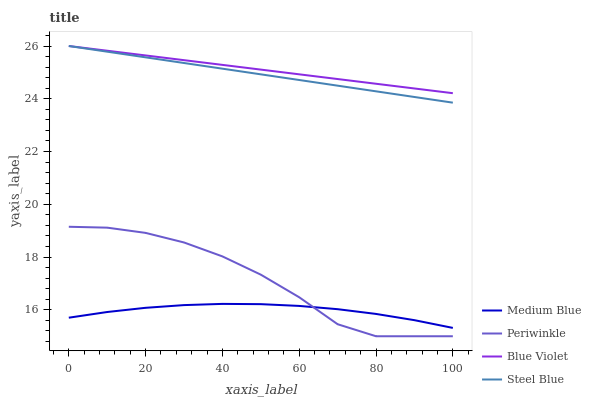Does Medium Blue have the minimum area under the curve?
Answer yes or no. Yes. Does Blue Violet have the maximum area under the curve?
Answer yes or no. Yes. Does Steel Blue have the minimum area under the curve?
Answer yes or no. No. Does Steel Blue have the maximum area under the curve?
Answer yes or no. No. Is Steel Blue the smoothest?
Answer yes or no. Yes. Is Periwinkle the roughest?
Answer yes or no. Yes. Is Medium Blue the smoothest?
Answer yes or no. No. Is Medium Blue the roughest?
Answer yes or no. No. Does Periwinkle have the lowest value?
Answer yes or no. Yes. Does Medium Blue have the lowest value?
Answer yes or no. No. Does Blue Violet have the highest value?
Answer yes or no. Yes. Does Medium Blue have the highest value?
Answer yes or no. No. Is Medium Blue less than Steel Blue?
Answer yes or no. Yes. Is Blue Violet greater than Medium Blue?
Answer yes or no. Yes. Does Steel Blue intersect Blue Violet?
Answer yes or no. Yes. Is Steel Blue less than Blue Violet?
Answer yes or no. No. Is Steel Blue greater than Blue Violet?
Answer yes or no. No. Does Medium Blue intersect Steel Blue?
Answer yes or no. No. 